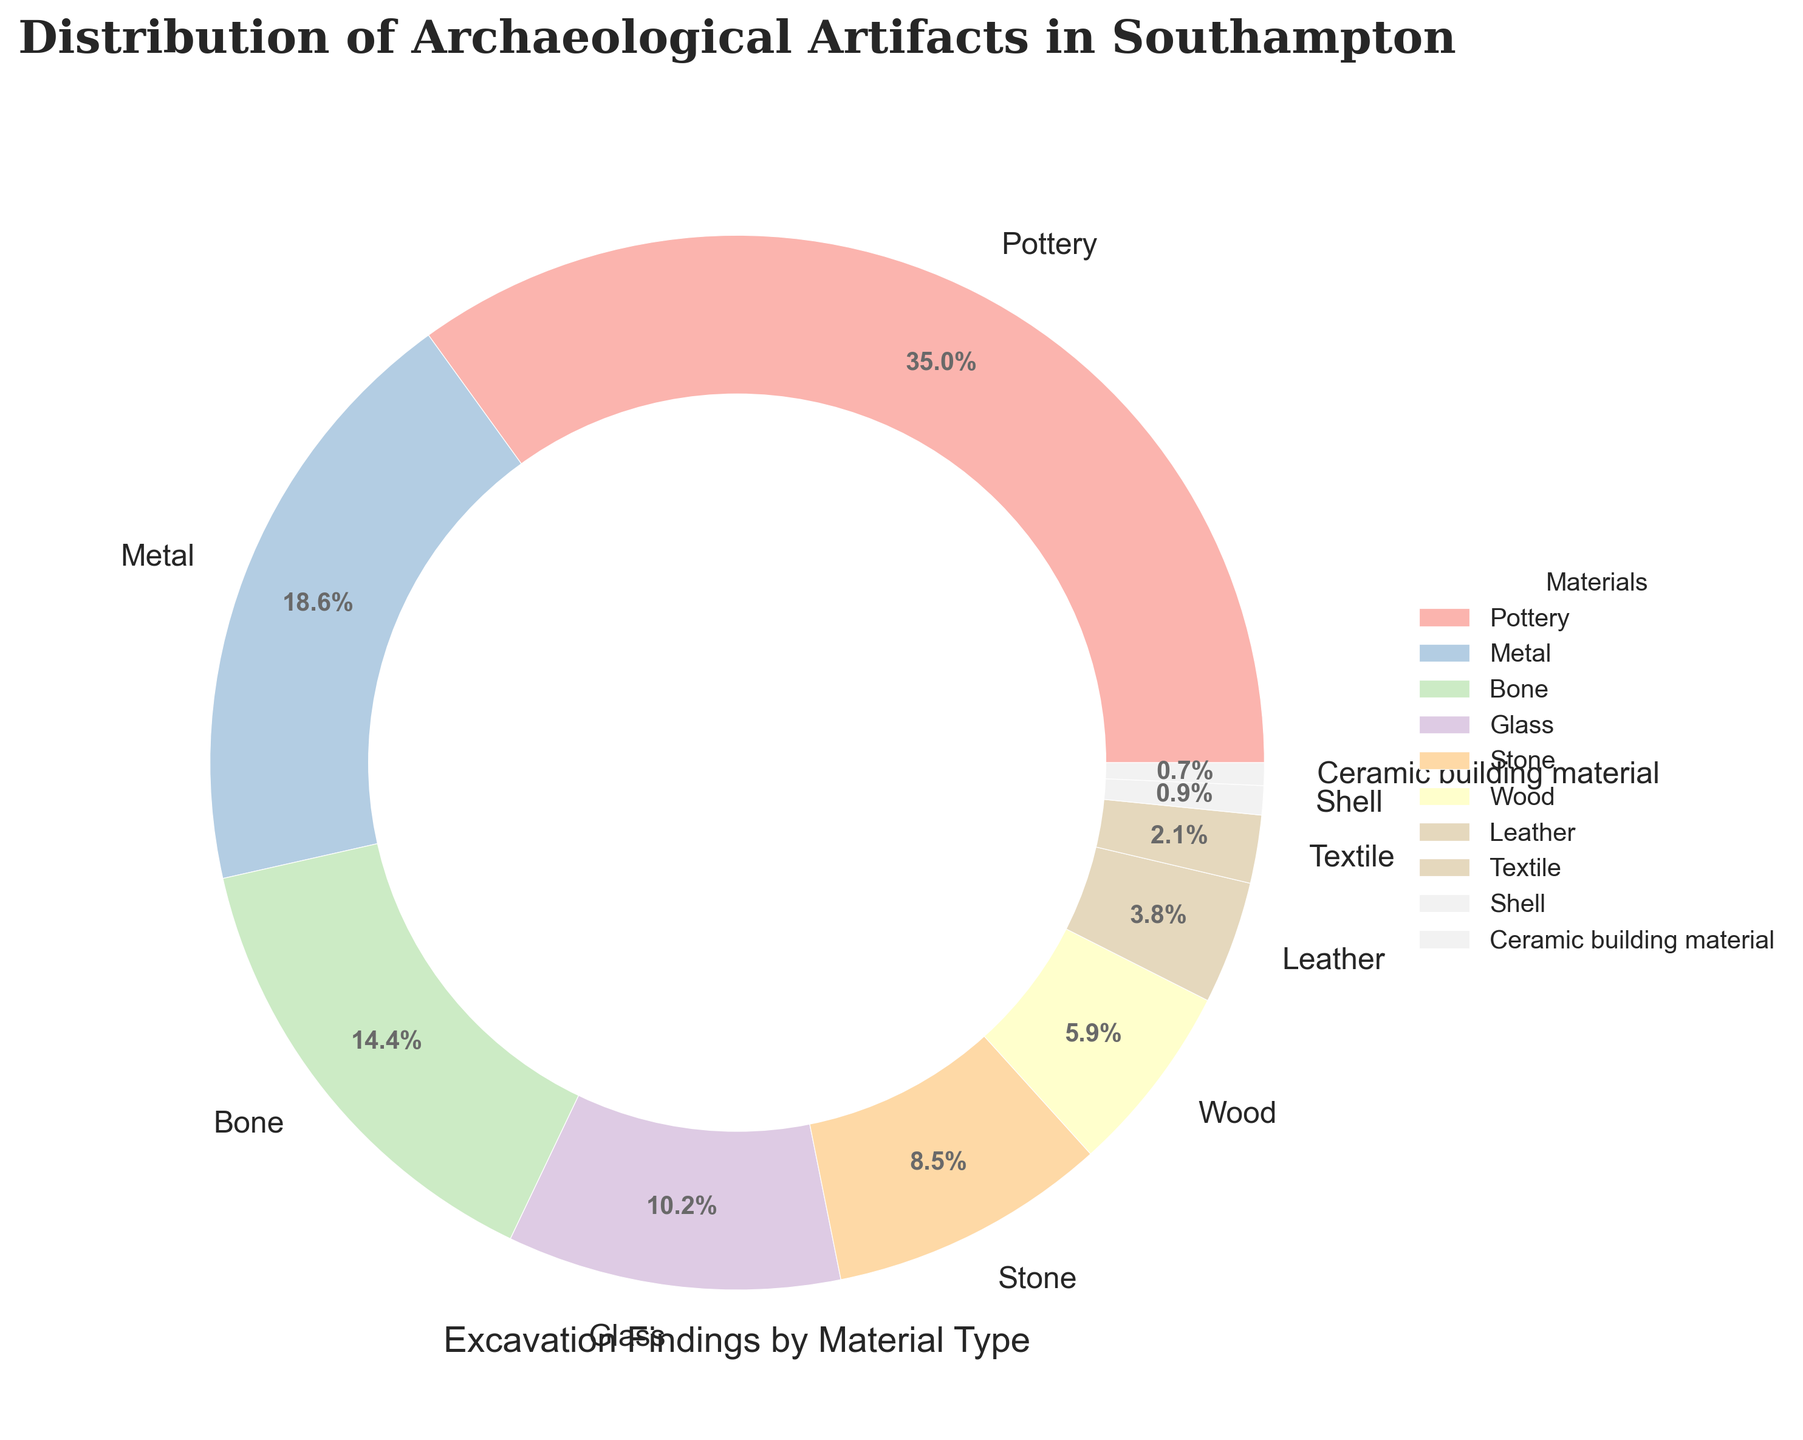What material has the highest percentage of found artifacts? Look at the pie chart to identify the segment with the largest size and its corresponding label.
Answer: Pottery What is the combined percentage of artifacts made of Metal and Bone? Add the percentages for Metal and Bone: 18.7% + 14.5% = 33.2%
Answer: 33.2% Which materials have less than 5% representation? Identify the segments with percentages less than 5%: Textile, Shell, and Ceramic building material
Answer: Textile, Shell, Ceramic building material By how much does the percentage of Pottery artifacts exceed that of Glass artifacts? Subtract the percentage of Glass from the percentage of Pottery: 35.2% - 10.3% = 24.9%
Answer: 24.9% What is the total percentage of artifacts made from organic materials (Wood, Bone, Textile, Leather, and Shell)? Sum the percentages for Wood, Bone, Textile, Leather, and Shell: 5.9% + 14.5% + 2.1% + 3.8% + 0.9% = 27.2%
Answer: 27.2% Which material has a percentage closest to that of Stone? Identify the percentage closest to 8.6% in the chart: Wood (5.9%)  = 2.7% difference and Glass (10.3%) = 1.7% difference
Answer: Glass What is the difference in percentage between the least and the most common artifact materials? Subtract the smallest percentage (Ceramic building material, 0.7%) from the largest percentage (Pottery, 35.2%): 35.2% - 0.7% = 34.5%
Answer: 34.5% Which types of artifacts make up more than 10% each of the total findings? Identify the segments with percentages greater than 10%: Pottery (35.2%), Metal (18.7%), and Bone (14.5%)
Answer: Pottery, Metal, Bone What is the average percentage of artifacts for Stone, Glass, and Metal? Sum the percentages and divide by the number of materials: (8.6% + 10.3% + 18.7%) / 3 = 37.6% / 3 = 12.53% (approx.)
Answer: 12.53% 